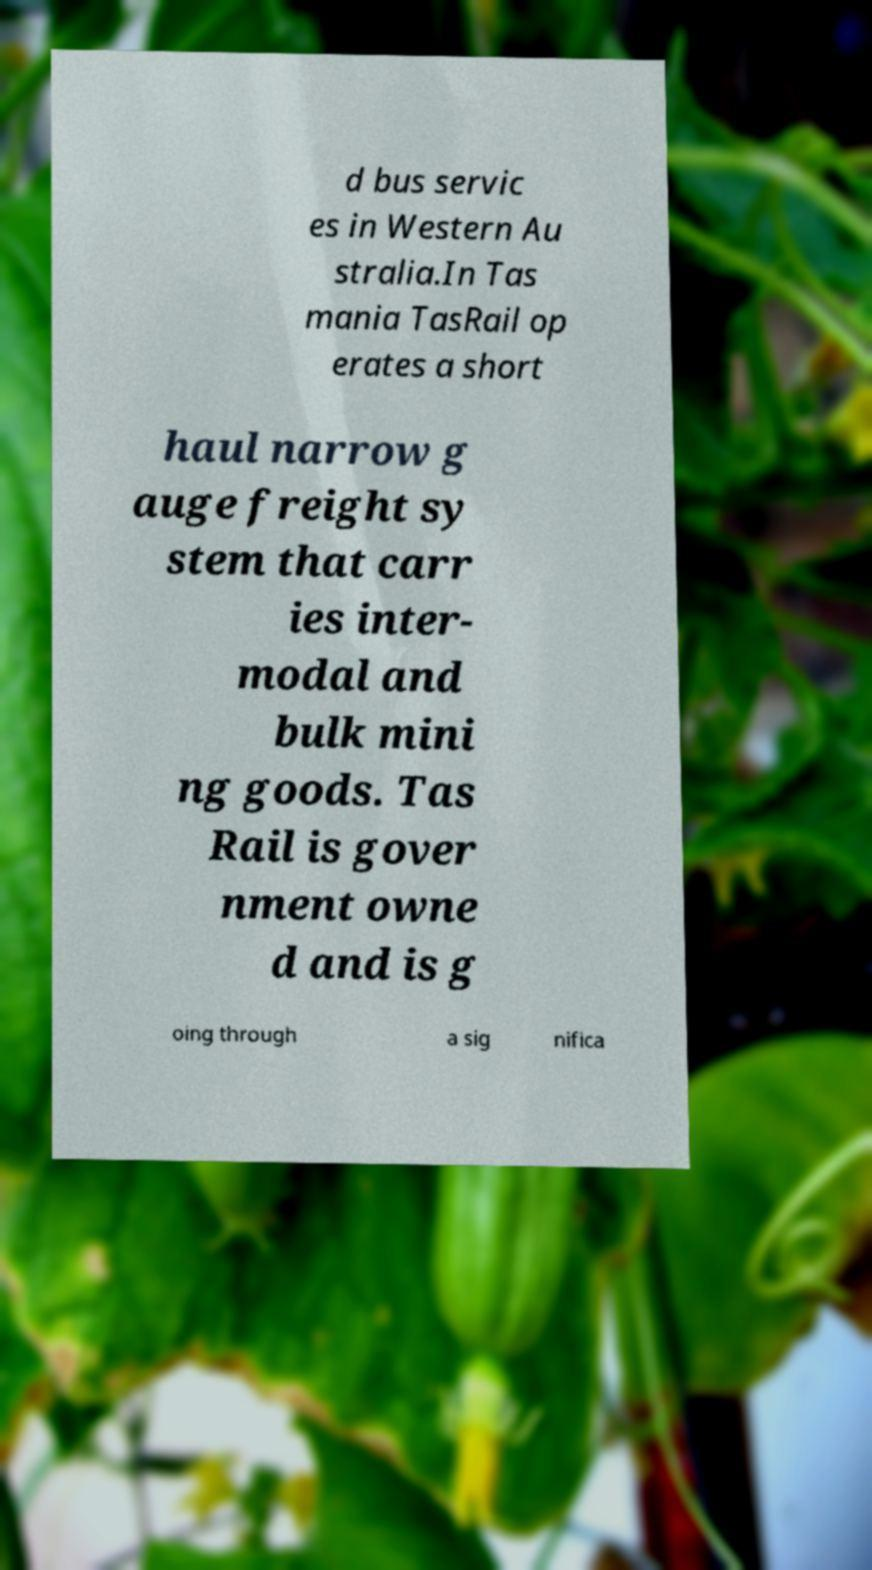Can you accurately transcribe the text from the provided image for me? d bus servic es in Western Au stralia.In Tas mania TasRail op erates a short haul narrow g auge freight sy stem that carr ies inter- modal and bulk mini ng goods. Tas Rail is gover nment owne d and is g oing through a sig nifica 